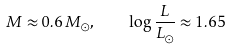Convert formula to latex. <formula><loc_0><loc_0><loc_500><loc_500>M \approx 0 . 6 \, M _ { \odot } , \quad \log \frac { L } { L _ { \odot } } \approx 1 . 6 5</formula> 